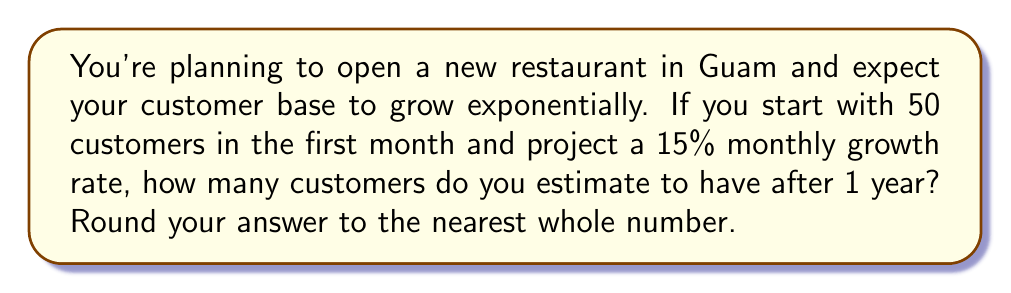Can you answer this question? Let's approach this step-by-step:

1) We start with an initial number of customers: $N_0 = 50$

2) The monthly growth rate is 15% or 0.15

3) We want to find the number of customers after 12 months (1 year)

4) The exponential growth formula is:
   $N(t) = N_0 * (1 + r)^t$
   Where:
   $N(t)$ is the number of customers after time $t$
   $N_0$ is the initial number of customers
   $r$ is the growth rate (as a decimal)
   $t$ is the number of time periods (months in this case)

5) Plugging in our values:
   $N(12) = 50 * (1 + 0.15)^{12}$

6) Simplify:
   $N(12) = 50 * (1.15)^{12}$

7) Calculate:
   $N(12) = 50 * 5.3503$
   $N(12) = 267.515$

8) Rounding to the nearest whole number:
   $N(12) \approx 268$
Answer: 268 customers 